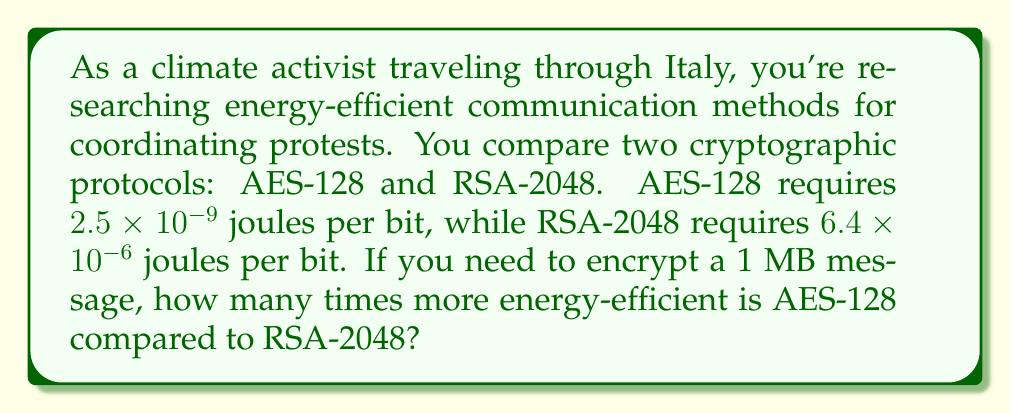Teach me how to tackle this problem. Let's approach this step-by-step:

1) First, we need to convert 1 MB to bits:
   $1 \text{ MB} = 1 \times 10^6 \text{ bytes}$
   $1 \text{ byte} = 8 \text{ bits}$
   $1 \text{ MB} = 1 \times 10^6 \times 8 = 8 \times 10^6 \text{ bits}$

2) Now, let's calculate the energy required for AES-128:
   $E_{AES} = 2.5 \times 10^{-9} \text{ J/bit} \times 8 \times 10^6 \text{ bits} = 2 \times 10^{-2} \text{ J}$

3) Calculate the energy required for RSA-2048:
   $E_{RSA} = 6.4 \times 10^{-6} \text{ J/bit} \times 8 \times 10^6 \text{ bits} = 51.2 \text{ J}$

4) To find how many times more efficient AES-128 is, we divide the energy of RSA-2048 by the energy of AES-128:
   $$\frac{E_{RSA}}{E_{AES}} = \frac{51.2 \text{ J}}{2 \times 10^{-2} \text{ J}} = 2560$$

Therefore, AES-128 is 2560 times more energy-efficient than RSA-2048 for this message size.
Answer: 2560 times 